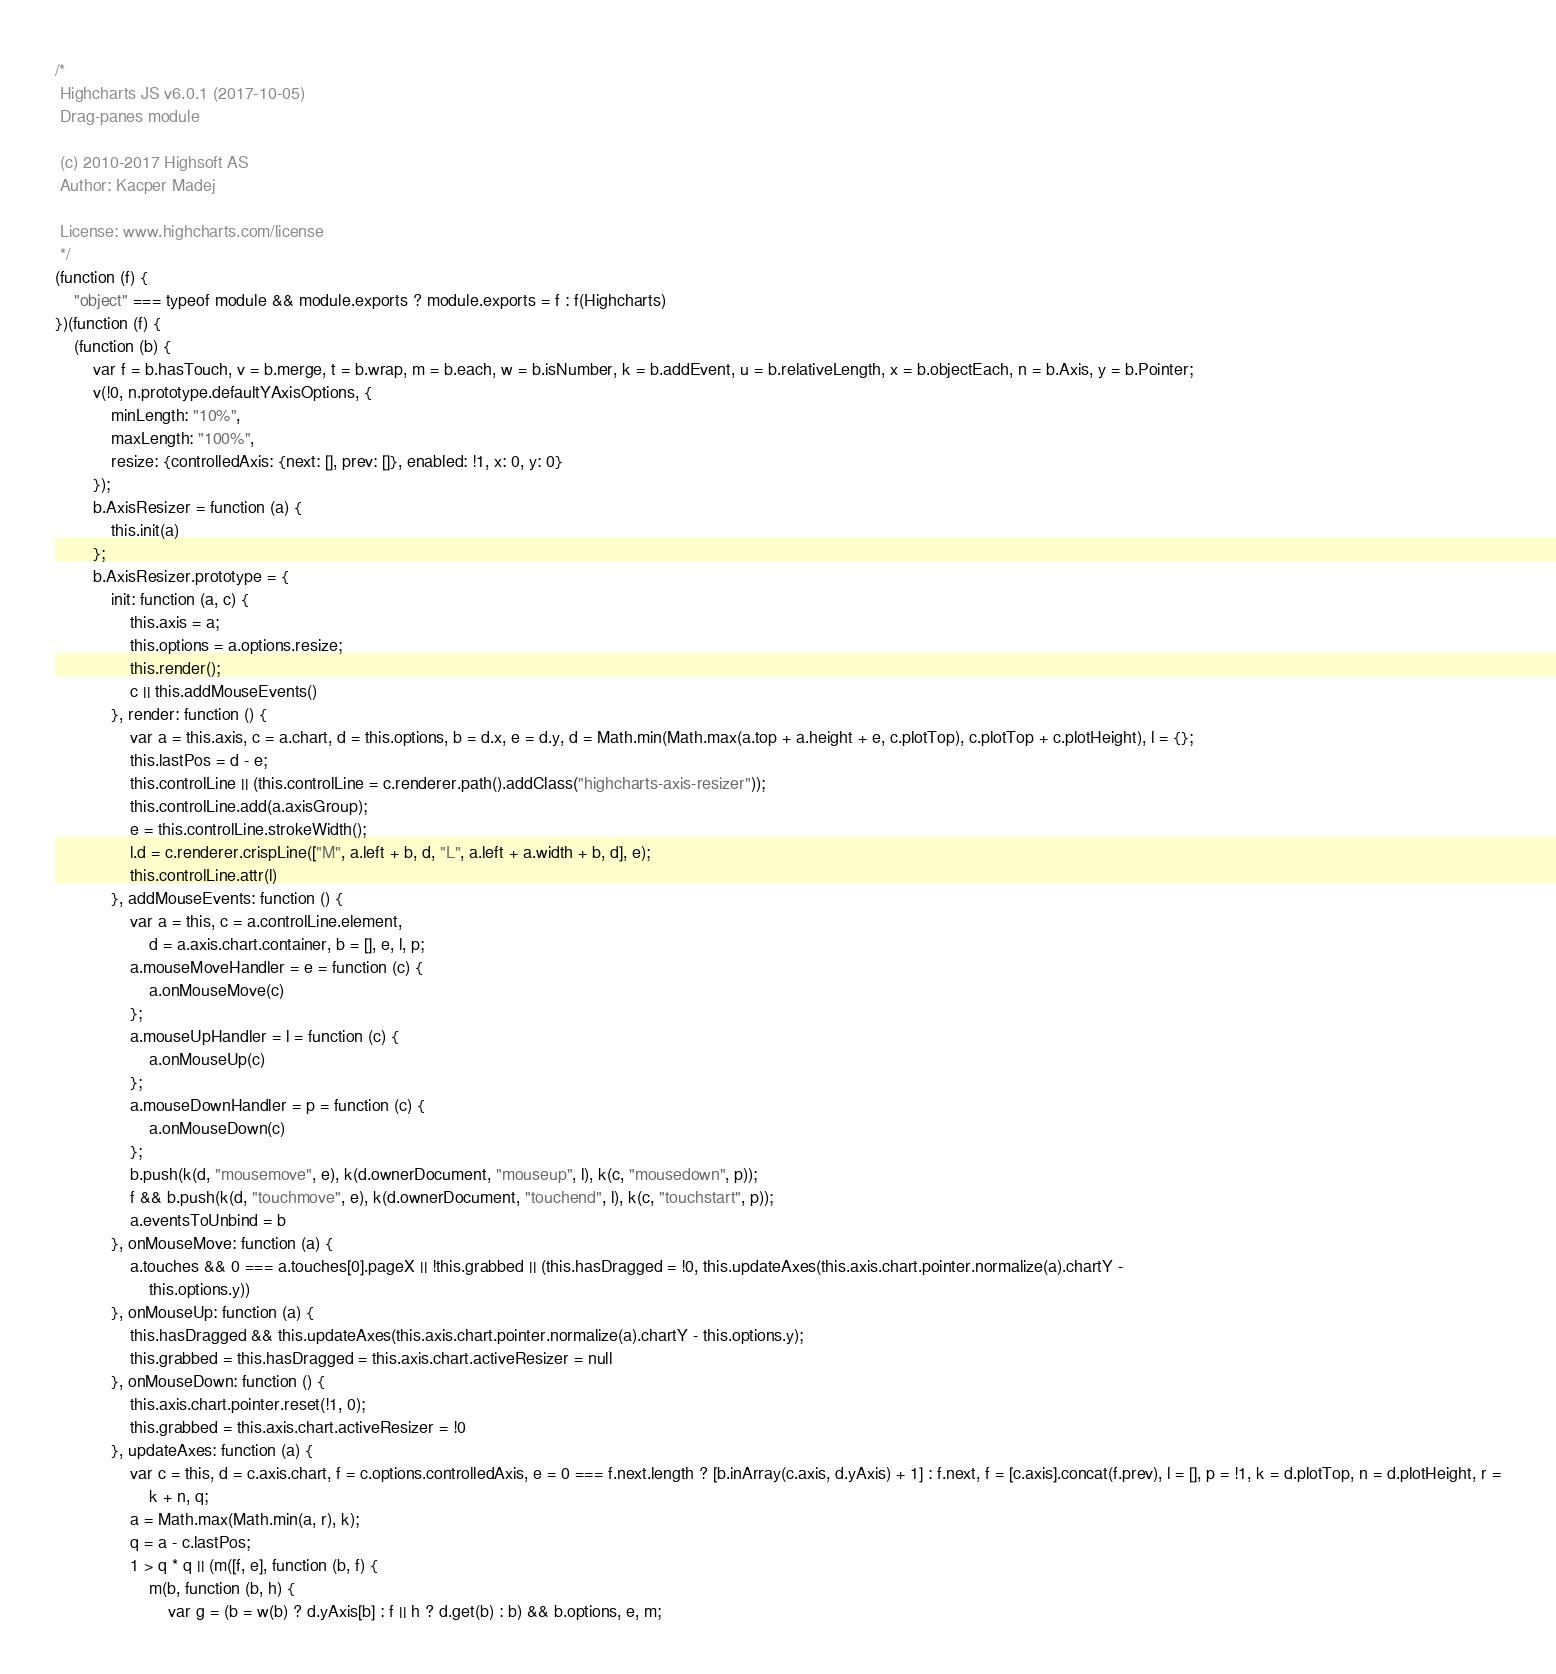<code> <loc_0><loc_0><loc_500><loc_500><_JavaScript_>/*
 Highcharts JS v6.0.1 (2017-10-05)
 Drag-panes module

 (c) 2010-2017 Highsoft AS
 Author: Kacper Madej

 License: www.highcharts.com/license
 */
(function (f) {
    "object" === typeof module && module.exports ? module.exports = f : f(Highcharts)
})(function (f) {
    (function (b) {
        var f = b.hasTouch, v = b.merge, t = b.wrap, m = b.each, w = b.isNumber, k = b.addEvent, u = b.relativeLength, x = b.objectEach, n = b.Axis, y = b.Pointer;
        v(!0, n.prototype.defaultYAxisOptions, {
            minLength: "10%",
            maxLength: "100%",
            resize: {controlledAxis: {next: [], prev: []}, enabled: !1, x: 0, y: 0}
        });
        b.AxisResizer = function (a) {
            this.init(a)
        };
        b.AxisResizer.prototype = {
            init: function (a, c) {
                this.axis = a;
                this.options = a.options.resize;
                this.render();
                c || this.addMouseEvents()
            }, render: function () {
                var a = this.axis, c = a.chart, d = this.options, b = d.x, e = d.y, d = Math.min(Math.max(a.top + a.height + e, c.plotTop), c.plotTop + c.plotHeight), l = {};
                this.lastPos = d - e;
                this.controlLine || (this.controlLine = c.renderer.path().addClass("highcharts-axis-resizer"));
                this.controlLine.add(a.axisGroup);
                e = this.controlLine.strokeWidth();
                l.d = c.renderer.crispLine(["M", a.left + b, d, "L", a.left + a.width + b, d], e);
                this.controlLine.attr(l)
            }, addMouseEvents: function () {
                var a = this, c = a.controlLine.element,
                    d = a.axis.chart.container, b = [], e, l, p;
                a.mouseMoveHandler = e = function (c) {
                    a.onMouseMove(c)
                };
                a.mouseUpHandler = l = function (c) {
                    a.onMouseUp(c)
                };
                a.mouseDownHandler = p = function (c) {
                    a.onMouseDown(c)
                };
                b.push(k(d, "mousemove", e), k(d.ownerDocument, "mouseup", l), k(c, "mousedown", p));
                f && b.push(k(d, "touchmove", e), k(d.ownerDocument, "touchend", l), k(c, "touchstart", p));
                a.eventsToUnbind = b
            }, onMouseMove: function (a) {
                a.touches && 0 === a.touches[0].pageX || !this.grabbed || (this.hasDragged = !0, this.updateAxes(this.axis.chart.pointer.normalize(a).chartY -
                    this.options.y))
            }, onMouseUp: function (a) {
                this.hasDragged && this.updateAxes(this.axis.chart.pointer.normalize(a).chartY - this.options.y);
                this.grabbed = this.hasDragged = this.axis.chart.activeResizer = null
            }, onMouseDown: function () {
                this.axis.chart.pointer.reset(!1, 0);
                this.grabbed = this.axis.chart.activeResizer = !0
            }, updateAxes: function (a) {
                var c = this, d = c.axis.chart, f = c.options.controlledAxis, e = 0 === f.next.length ? [b.inArray(c.axis, d.yAxis) + 1] : f.next, f = [c.axis].concat(f.prev), l = [], p = !1, k = d.plotTop, n = d.plotHeight, r =
                    k + n, q;
                a = Math.max(Math.min(a, r), k);
                q = a - c.lastPos;
                1 > q * q || (m([f, e], function (b, f) {
                    m(b, function (b, h) {
                        var g = (b = w(b) ? d.yAxis[b] : f || h ? d.get(b) : b) && b.options, e, m;</code> 